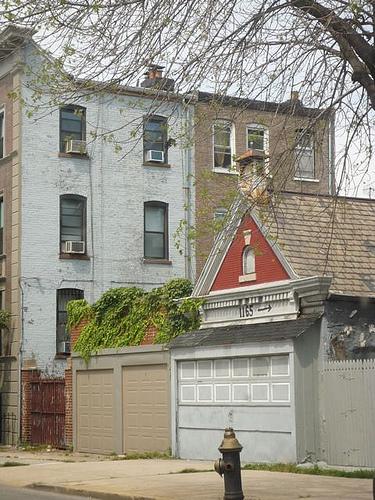Who is the street?
Write a very short answer. No one. Are there benches in front of the building?
Answer briefly. No. Are there cars on the street?
Keep it brief. No. Is this a private home?
Answer briefly. Yes. What is the building made of?
Concise answer only. Brick. What color is the door?
Keep it brief. White. What direction is the arrow pointing?
Keep it brief. Right. 